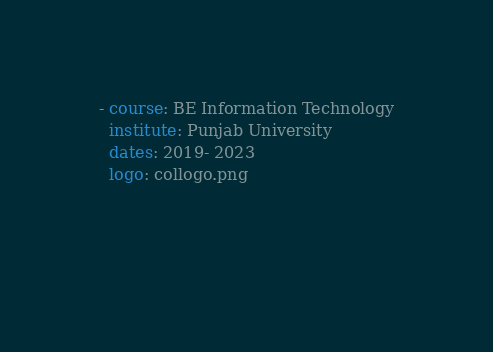<code> <loc_0><loc_0><loc_500><loc_500><_YAML_>- course: BE Information Technology
  institute: Punjab University
  dates: 2019- 2023
  logo: collogo.png
  

  
</code> 